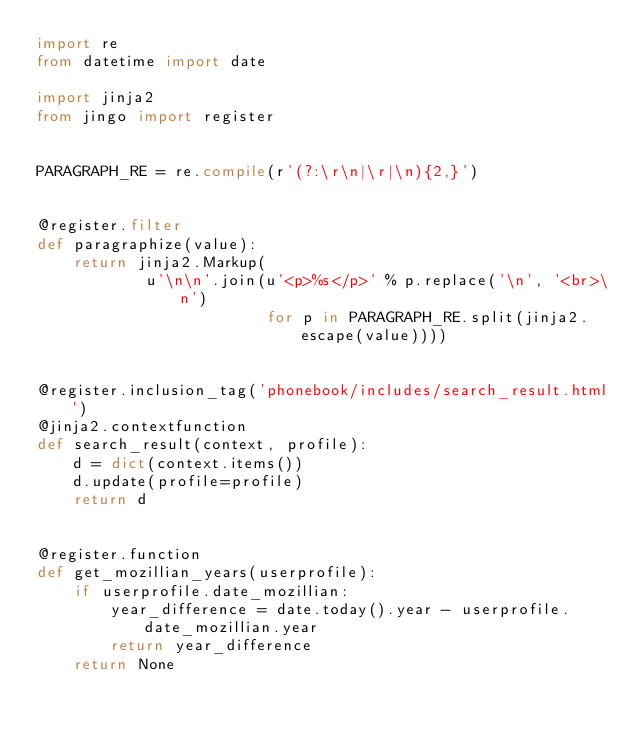<code> <loc_0><loc_0><loc_500><loc_500><_Python_>import re
from datetime import date

import jinja2
from jingo import register


PARAGRAPH_RE = re.compile(r'(?:\r\n|\r|\n){2,}')


@register.filter
def paragraphize(value):
    return jinja2.Markup(
            u'\n\n'.join(u'<p>%s</p>' % p.replace('\n', '<br>\n')
                         for p in PARAGRAPH_RE.split(jinja2.escape(value))))


@register.inclusion_tag('phonebook/includes/search_result.html')
@jinja2.contextfunction
def search_result(context, profile):
    d = dict(context.items())
    d.update(profile=profile)
    return d


@register.function
def get_mozillian_years(userprofile):
    if userprofile.date_mozillian:
        year_difference = date.today().year - userprofile.date_mozillian.year
        return year_difference
    return None
</code> 